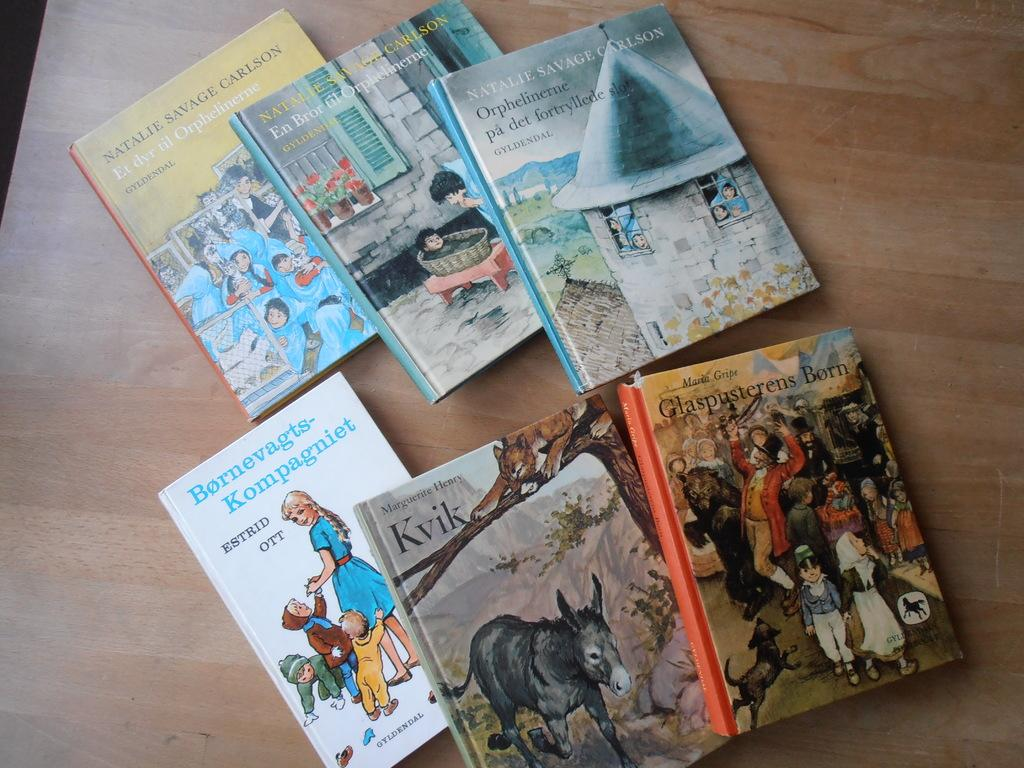<image>
Give a short and clear explanation of the subsequent image. 6 children's books by authors such as Estrid Ott and Maria Gripe are on a table. 